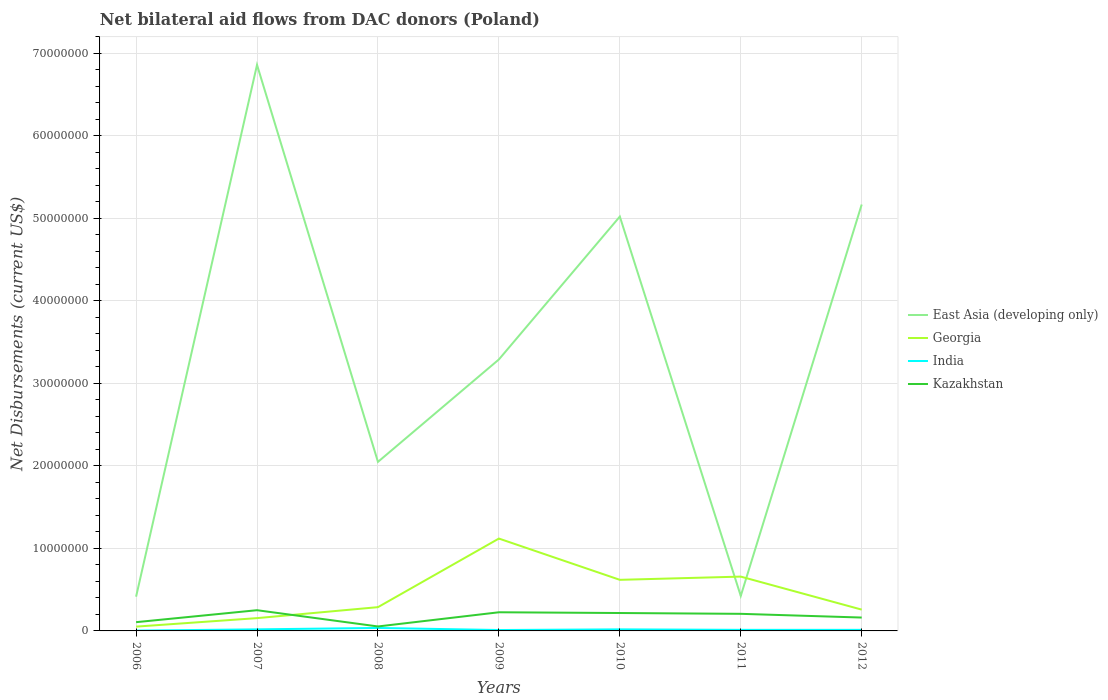How many different coloured lines are there?
Ensure brevity in your answer.  4. Across all years, what is the maximum net bilateral aid flows in East Asia (developing only)?
Ensure brevity in your answer.  4.15e+06. What is the total net bilateral aid flows in Kazakhstan in the graph?
Your answer should be very brief. -1.53e+06. What is the difference between the highest and the second highest net bilateral aid flows in East Asia (developing only)?
Your response must be concise. 6.44e+07. What is the difference between the highest and the lowest net bilateral aid flows in India?
Ensure brevity in your answer.  3. What is the difference between two consecutive major ticks on the Y-axis?
Offer a terse response. 1.00e+07. Are the values on the major ticks of Y-axis written in scientific E-notation?
Provide a short and direct response. No. Does the graph contain any zero values?
Give a very brief answer. No. Where does the legend appear in the graph?
Your answer should be compact. Center right. How many legend labels are there?
Offer a terse response. 4. What is the title of the graph?
Offer a very short reply. Net bilateral aid flows from DAC donors (Poland). Does "Thailand" appear as one of the legend labels in the graph?
Make the answer very short. No. What is the label or title of the X-axis?
Provide a short and direct response. Years. What is the label or title of the Y-axis?
Give a very brief answer. Net Disbursements (current US$). What is the Net Disbursements (current US$) in East Asia (developing only) in 2006?
Ensure brevity in your answer.  4.15e+06. What is the Net Disbursements (current US$) of Georgia in 2006?
Ensure brevity in your answer.  5.20e+05. What is the Net Disbursements (current US$) in India in 2006?
Provide a succinct answer. 4.00e+04. What is the Net Disbursements (current US$) of Kazakhstan in 2006?
Ensure brevity in your answer.  1.06e+06. What is the Net Disbursements (current US$) in East Asia (developing only) in 2007?
Provide a short and direct response. 6.86e+07. What is the Net Disbursements (current US$) of Georgia in 2007?
Offer a very short reply. 1.55e+06. What is the Net Disbursements (current US$) in Kazakhstan in 2007?
Keep it short and to the point. 2.51e+06. What is the Net Disbursements (current US$) in East Asia (developing only) in 2008?
Make the answer very short. 2.05e+07. What is the Net Disbursements (current US$) in Georgia in 2008?
Offer a very short reply. 2.88e+06. What is the Net Disbursements (current US$) of Kazakhstan in 2008?
Your answer should be compact. 5.40e+05. What is the Net Disbursements (current US$) of East Asia (developing only) in 2009?
Ensure brevity in your answer.  3.29e+07. What is the Net Disbursements (current US$) in Georgia in 2009?
Give a very brief answer. 1.12e+07. What is the Net Disbursements (current US$) in India in 2009?
Keep it short and to the point. 1.10e+05. What is the Net Disbursements (current US$) of Kazakhstan in 2009?
Offer a very short reply. 2.26e+06. What is the Net Disbursements (current US$) of East Asia (developing only) in 2010?
Keep it short and to the point. 5.02e+07. What is the Net Disbursements (current US$) in Georgia in 2010?
Your answer should be compact. 6.19e+06. What is the Net Disbursements (current US$) of Kazakhstan in 2010?
Offer a very short reply. 2.17e+06. What is the Net Disbursements (current US$) in East Asia (developing only) in 2011?
Your response must be concise. 4.24e+06. What is the Net Disbursements (current US$) in Georgia in 2011?
Provide a short and direct response. 6.58e+06. What is the Net Disbursements (current US$) of Kazakhstan in 2011?
Your response must be concise. 2.07e+06. What is the Net Disbursements (current US$) of East Asia (developing only) in 2012?
Offer a terse response. 5.17e+07. What is the Net Disbursements (current US$) in Georgia in 2012?
Offer a terse response. 2.58e+06. What is the Net Disbursements (current US$) in India in 2012?
Your answer should be very brief. 1.30e+05. What is the Net Disbursements (current US$) in Kazakhstan in 2012?
Your answer should be very brief. 1.62e+06. Across all years, what is the maximum Net Disbursements (current US$) in East Asia (developing only)?
Make the answer very short. 6.86e+07. Across all years, what is the maximum Net Disbursements (current US$) in Georgia?
Give a very brief answer. 1.12e+07. Across all years, what is the maximum Net Disbursements (current US$) of India?
Offer a very short reply. 3.60e+05. Across all years, what is the maximum Net Disbursements (current US$) in Kazakhstan?
Your answer should be very brief. 2.51e+06. Across all years, what is the minimum Net Disbursements (current US$) in East Asia (developing only)?
Your response must be concise. 4.15e+06. Across all years, what is the minimum Net Disbursements (current US$) of Georgia?
Keep it short and to the point. 5.20e+05. Across all years, what is the minimum Net Disbursements (current US$) of Kazakhstan?
Provide a short and direct response. 5.40e+05. What is the total Net Disbursements (current US$) of East Asia (developing only) in the graph?
Your answer should be compact. 2.32e+08. What is the total Net Disbursements (current US$) in Georgia in the graph?
Offer a terse response. 3.15e+07. What is the total Net Disbursements (current US$) of India in the graph?
Provide a short and direct response. 1.15e+06. What is the total Net Disbursements (current US$) in Kazakhstan in the graph?
Your answer should be compact. 1.22e+07. What is the difference between the Net Disbursements (current US$) in East Asia (developing only) in 2006 and that in 2007?
Offer a very short reply. -6.44e+07. What is the difference between the Net Disbursements (current US$) in Georgia in 2006 and that in 2007?
Keep it short and to the point. -1.03e+06. What is the difference between the Net Disbursements (current US$) in Kazakhstan in 2006 and that in 2007?
Make the answer very short. -1.45e+06. What is the difference between the Net Disbursements (current US$) in East Asia (developing only) in 2006 and that in 2008?
Ensure brevity in your answer.  -1.63e+07. What is the difference between the Net Disbursements (current US$) in Georgia in 2006 and that in 2008?
Your response must be concise. -2.36e+06. What is the difference between the Net Disbursements (current US$) in India in 2006 and that in 2008?
Provide a succinct answer. -3.20e+05. What is the difference between the Net Disbursements (current US$) in Kazakhstan in 2006 and that in 2008?
Make the answer very short. 5.20e+05. What is the difference between the Net Disbursements (current US$) in East Asia (developing only) in 2006 and that in 2009?
Make the answer very short. -2.87e+07. What is the difference between the Net Disbursements (current US$) of Georgia in 2006 and that in 2009?
Keep it short and to the point. -1.07e+07. What is the difference between the Net Disbursements (current US$) in India in 2006 and that in 2009?
Provide a succinct answer. -7.00e+04. What is the difference between the Net Disbursements (current US$) in Kazakhstan in 2006 and that in 2009?
Keep it short and to the point. -1.20e+06. What is the difference between the Net Disbursements (current US$) of East Asia (developing only) in 2006 and that in 2010?
Your answer should be very brief. -4.60e+07. What is the difference between the Net Disbursements (current US$) in Georgia in 2006 and that in 2010?
Your answer should be compact. -5.67e+06. What is the difference between the Net Disbursements (current US$) in India in 2006 and that in 2010?
Provide a succinct answer. -1.50e+05. What is the difference between the Net Disbursements (current US$) of Kazakhstan in 2006 and that in 2010?
Make the answer very short. -1.11e+06. What is the difference between the Net Disbursements (current US$) of Georgia in 2006 and that in 2011?
Provide a short and direct response. -6.06e+06. What is the difference between the Net Disbursements (current US$) in India in 2006 and that in 2011?
Provide a succinct answer. -9.00e+04. What is the difference between the Net Disbursements (current US$) of Kazakhstan in 2006 and that in 2011?
Offer a terse response. -1.01e+06. What is the difference between the Net Disbursements (current US$) of East Asia (developing only) in 2006 and that in 2012?
Keep it short and to the point. -4.75e+07. What is the difference between the Net Disbursements (current US$) of Georgia in 2006 and that in 2012?
Your answer should be very brief. -2.06e+06. What is the difference between the Net Disbursements (current US$) in India in 2006 and that in 2012?
Provide a short and direct response. -9.00e+04. What is the difference between the Net Disbursements (current US$) in Kazakhstan in 2006 and that in 2012?
Your answer should be very brief. -5.60e+05. What is the difference between the Net Disbursements (current US$) of East Asia (developing only) in 2007 and that in 2008?
Your response must be concise. 4.81e+07. What is the difference between the Net Disbursements (current US$) in Georgia in 2007 and that in 2008?
Offer a very short reply. -1.33e+06. What is the difference between the Net Disbursements (current US$) in Kazakhstan in 2007 and that in 2008?
Provide a short and direct response. 1.97e+06. What is the difference between the Net Disbursements (current US$) in East Asia (developing only) in 2007 and that in 2009?
Keep it short and to the point. 3.57e+07. What is the difference between the Net Disbursements (current US$) in Georgia in 2007 and that in 2009?
Keep it short and to the point. -9.64e+06. What is the difference between the Net Disbursements (current US$) of India in 2007 and that in 2009?
Your answer should be very brief. 8.00e+04. What is the difference between the Net Disbursements (current US$) in East Asia (developing only) in 2007 and that in 2010?
Your response must be concise. 1.84e+07. What is the difference between the Net Disbursements (current US$) in Georgia in 2007 and that in 2010?
Provide a succinct answer. -4.64e+06. What is the difference between the Net Disbursements (current US$) of Kazakhstan in 2007 and that in 2010?
Your response must be concise. 3.40e+05. What is the difference between the Net Disbursements (current US$) of East Asia (developing only) in 2007 and that in 2011?
Provide a succinct answer. 6.43e+07. What is the difference between the Net Disbursements (current US$) of Georgia in 2007 and that in 2011?
Ensure brevity in your answer.  -5.03e+06. What is the difference between the Net Disbursements (current US$) of Kazakhstan in 2007 and that in 2011?
Ensure brevity in your answer.  4.40e+05. What is the difference between the Net Disbursements (current US$) of East Asia (developing only) in 2007 and that in 2012?
Offer a terse response. 1.69e+07. What is the difference between the Net Disbursements (current US$) in Georgia in 2007 and that in 2012?
Offer a terse response. -1.03e+06. What is the difference between the Net Disbursements (current US$) of Kazakhstan in 2007 and that in 2012?
Keep it short and to the point. 8.90e+05. What is the difference between the Net Disbursements (current US$) of East Asia (developing only) in 2008 and that in 2009?
Offer a terse response. -1.24e+07. What is the difference between the Net Disbursements (current US$) in Georgia in 2008 and that in 2009?
Ensure brevity in your answer.  -8.31e+06. What is the difference between the Net Disbursements (current US$) of India in 2008 and that in 2009?
Offer a terse response. 2.50e+05. What is the difference between the Net Disbursements (current US$) of Kazakhstan in 2008 and that in 2009?
Give a very brief answer. -1.72e+06. What is the difference between the Net Disbursements (current US$) in East Asia (developing only) in 2008 and that in 2010?
Offer a terse response. -2.97e+07. What is the difference between the Net Disbursements (current US$) in Georgia in 2008 and that in 2010?
Make the answer very short. -3.31e+06. What is the difference between the Net Disbursements (current US$) of Kazakhstan in 2008 and that in 2010?
Your answer should be very brief. -1.63e+06. What is the difference between the Net Disbursements (current US$) in East Asia (developing only) in 2008 and that in 2011?
Provide a succinct answer. 1.62e+07. What is the difference between the Net Disbursements (current US$) of Georgia in 2008 and that in 2011?
Give a very brief answer. -3.70e+06. What is the difference between the Net Disbursements (current US$) of Kazakhstan in 2008 and that in 2011?
Your answer should be very brief. -1.53e+06. What is the difference between the Net Disbursements (current US$) in East Asia (developing only) in 2008 and that in 2012?
Ensure brevity in your answer.  -3.12e+07. What is the difference between the Net Disbursements (current US$) in Georgia in 2008 and that in 2012?
Ensure brevity in your answer.  3.00e+05. What is the difference between the Net Disbursements (current US$) of Kazakhstan in 2008 and that in 2012?
Provide a short and direct response. -1.08e+06. What is the difference between the Net Disbursements (current US$) in East Asia (developing only) in 2009 and that in 2010?
Your answer should be compact. -1.73e+07. What is the difference between the Net Disbursements (current US$) of Kazakhstan in 2009 and that in 2010?
Provide a short and direct response. 9.00e+04. What is the difference between the Net Disbursements (current US$) of East Asia (developing only) in 2009 and that in 2011?
Make the answer very short. 2.86e+07. What is the difference between the Net Disbursements (current US$) in Georgia in 2009 and that in 2011?
Offer a terse response. 4.61e+06. What is the difference between the Net Disbursements (current US$) in India in 2009 and that in 2011?
Provide a succinct answer. -2.00e+04. What is the difference between the Net Disbursements (current US$) of East Asia (developing only) in 2009 and that in 2012?
Provide a short and direct response. -1.88e+07. What is the difference between the Net Disbursements (current US$) of Georgia in 2009 and that in 2012?
Provide a short and direct response. 8.61e+06. What is the difference between the Net Disbursements (current US$) in India in 2009 and that in 2012?
Your answer should be compact. -2.00e+04. What is the difference between the Net Disbursements (current US$) of Kazakhstan in 2009 and that in 2012?
Make the answer very short. 6.40e+05. What is the difference between the Net Disbursements (current US$) in East Asia (developing only) in 2010 and that in 2011?
Keep it short and to the point. 4.60e+07. What is the difference between the Net Disbursements (current US$) of Georgia in 2010 and that in 2011?
Your answer should be very brief. -3.90e+05. What is the difference between the Net Disbursements (current US$) of Kazakhstan in 2010 and that in 2011?
Your answer should be very brief. 1.00e+05. What is the difference between the Net Disbursements (current US$) of East Asia (developing only) in 2010 and that in 2012?
Offer a very short reply. -1.46e+06. What is the difference between the Net Disbursements (current US$) of Georgia in 2010 and that in 2012?
Keep it short and to the point. 3.61e+06. What is the difference between the Net Disbursements (current US$) of India in 2010 and that in 2012?
Your answer should be very brief. 6.00e+04. What is the difference between the Net Disbursements (current US$) of East Asia (developing only) in 2011 and that in 2012?
Make the answer very short. -4.74e+07. What is the difference between the Net Disbursements (current US$) of Kazakhstan in 2011 and that in 2012?
Give a very brief answer. 4.50e+05. What is the difference between the Net Disbursements (current US$) of East Asia (developing only) in 2006 and the Net Disbursements (current US$) of Georgia in 2007?
Your answer should be very brief. 2.60e+06. What is the difference between the Net Disbursements (current US$) in East Asia (developing only) in 2006 and the Net Disbursements (current US$) in India in 2007?
Provide a short and direct response. 3.96e+06. What is the difference between the Net Disbursements (current US$) in East Asia (developing only) in 2006 and the Net Disbursements (current US$) in Kazakhstan in 2007?
Give a very brief answer. 1.64e+06. What is the difference between the Net Disbursements (current US$) in Georgia in 2006 and the Net Disbursements (current US$) in India in 2007?
Offer a terse response. 3.30e+05. What is the difference between the Net Disbursements (current US$) of Georgia in 2006 and the Net Disbursements (current US$) of Kazakhstan in 2007?
Offer a terse response. -1.99e+06. What is the difference between the Net Disbursements (current US$) of India in 2006 and the Net Disbursements (current US$) of Kazakhstan in 2007?
Keep it short and to the point. -2.47e+06. What is the difference between the Net Disbursements (current US$) of East Asia (developing only) in 2006 and the Net Disbursements (current US$) of Georgia in 2008?
Give a very brief answer. 1.27e+06. What is the difference between the Net Disbursements (current US$) in East Asia (developing only) in 2006 and the Net Disbursements (current US$) in India in 2008?
Offer a very short reply. 3.79e+06. What is the difference between the Net Disbursements (current US$) of East Asia (developing only) in 2006 and the Net Disbursements (current US$) of Kazakhstan in 2008?
Offer a terse response. 3.61e+06. What is the difference between the Net Disbursements (current US$) of Georgia in 2006 and the Net Disbursements (current US$) of Kazakhstan in 2008?
Offer a very short reply. -2.00e+04. What is the difference between the Net Disbursements (current US$) in India in 2006 and the Net Disbursements (current US$) in Kazakhstan in 2008?
Your answer should be very brief. -5.00e+05. What is the difference between the Net Disbursements (current US$) in East Asia (developing only) in 2006 and the Net Disbursements (current US$) in Georgia in 2009?
Your answer should be very brief. -7.04e+06. What is the difference between the Net Disbursements (current US$) in East Asia (developing only) in 2006 and the Net Disbursements (current US$) in India in 2009?
Make the answer very short. 4.04e+06. What is the difference between the Net Disbursements (current US$) of East Asia (developing only) in 2006 and the Net Disbursements (current US$) of Kazakhstan in 2009?
Provide a short and direct response. 1.89e+06. What is the difference between the Net Disbursements (current US$) of Georgia in 2006 and the Net Disbursements (current US$) of Kazakhstan in 2009?
Offer a very short reply. -1.74e+06. What is the difference between the Net Disbursements (current US$) in India in 2006 and the Net Disbursements (current US$) in Kazakhstan in 2009?
Offer a terse response. -2.22e+06. What is the difference between the Net Disbursements (current US$) in East Asia (developing only) in 2006 and the Net Disbursements (current US$) in Georgia in 2010?
Provide a short and direct response. -2.04e+06. What is the difference between the Net Disbursements (current US$) in East Asia (developing only) in 2006 and the Net Disbursements (current US$) in India in 2010?
Make the answer very short. 3.96e+06. What is the difference between the Net Disbursements (current US$) of East Asia (developing only) in 2006 and the Net Disbursements (current US$) of Kazakhstan in 2010?
Keep it short and to the point. 1.98e+06. What is the difference between the Net Disbursements (current US$) in Georgia in 2006 and the Net Disbursements (current US$) in India in 2010?
Give a very brief answer. 3.30e+05. What is the difference between the Net Disbursements (current US$) in Georgia in 2006 and the Net Disbursements (current US$) in Kazakhstan in 2010?
Provide a short and direct response. -1.65e+06. What is the difference between the Net Disbursements (current US$) of India in 2006 and the Net Disbursements (current US$) of Kazakhstan in 2010?
Your answer should be compact. -2.13e+06. What is the difference between the Net Disbursements (current US$) in East Asia (developing only) in 2006 and the Net Disbursements (current US$) in Georgia in 2011?
Offer a terse response. -2.43e+06. What is the difference between the Net Disbursements (current US$) of East Asia (developing only) in 2006 and the Net Disbursements (current US$) of India in 2011?
Your answer should be compact. 4.02e+06. What is the difference between the Net Disbursements (current US$) in East Asia (developing only) in 2006 and the Net Disbursements (current US$) in Kazakhstan in 2011?
Provide a succinct answer. 2.08e+06. What is the difference between the Net Disbursements (current US$) in Georgia in 2006 and the Net Disbursements (current US$) in Kazakhstan in 2011?
Offer a terse response. -1.55e+06. What is the difference between the Net Disbursements (current US$) in India in 2006 and the Net Disbursements (current US$) in Kazakhstan in 2011?
Give a very brief answer. -2.03e+06. What is the difference between the Net Disbursements (current US$) of East Asia (developing only) in 2006 and the Net Disbursements (current US$) of Georgia in 2012?
Make the answer very short. 1.57e+06. What is the difference between the Net Disbursements (current US$) in East Asia (developing only) in 2006 and the Net Disbursements (current US$) in India in 2012?
Your response must be concise. 4.02e+06. What is the difference between the Net Disbursements (current US$) of East Asia (developing only) in 2006 and the Net Disbursements (current US$) of Kazakhstan in 2012?
Your answer should be very brief. 2.53e+06. What is the difference between the Net Disbursements (current US$) in Georgia in 2006 and the Net Disbursements (current US$) in India in 2012?
Provide a short and direct response. 3.90e+05. What is the difference between the Net Disbursements (current US$) in Georgia in 2006 and the Net Disbursements (current US$) in Kazakhstan in 2012?
Offer a very short reply. -1.10e+06. What is the difference between the Net Disbursements (current US$) in India in 2006 and the Net Disbursements (current US$) in Kazakhstan in 2012?
Keep it short and to the point. -1.58e+06. What is the difference between the Net Disbursements (current US$) of East Asia (developing only) in 2007 and the Net Disbursements (current US$) of Georgia in 2008?
Your answer should be compact. 6.57e+07. What is the difference between the Net Disbursements (current US$) of East Asia (developing only) in 2007 and the Net Disbursements (current US$) of India in 2008?
Provide a succinct answer. 6.82e+07. What is the difference between the Net Disbursements (current US$) of East Asia (developing only) in 2007 and the Net Disbursements (current US$) of Kazakhstan in 2008?
Ensure brevity in your answer.  6.80e+07. What is the difference between the Net Disbursements (current US$) in Georgia in 2007 and the Net Disbursements (current US$) in India in 2008?
Give a very brief answer. 1.19e+06. What is the difference between the Net Disbursements (current US$) in Georgia in 2007 and the Net Disbursements (current US$) in Kazakhstan in 2008?
Provide a succinct answer. 1.01e+06. What is the difference between the Net Disbursements (current US$) of India in 2007 and the Net Disbursements (current US$) of Kazakhstan in 2008?
Make the answer very short. -3.50e+05. What is the difference between the Net Disbursements (current US$) in East Asia (developing only) in 2007 and the Net Disbursements (current US$) in Georgia in 2009?
Your response must be concise. 5.74e+07. What is the difference between the Net Disbursements (current US$) of East Asia (developing only) in 2007 and the Net Disbursements (current US$) of India in 2009?
Your answer should be compact. 6.85e+07. What is the difference between the Net Disbursements (current US$) of East Asia (developing only) in 2007 and the Net Disbursements (current US$) of Kazakhstan in 2009?
Provide a succinct answer. 6.63e+07. What is the difference between the Net Disbursements (current US$) of Georgia in 2007 and the Net Disbursements (current US$) of India in 2009?
Your answer should be compact. 1.44e+06. What is the difference between the Net Disbursements (current US$) in Georgia in 2007 and the Net Disbursements (current US$) in Kazakhstan in 2009?
Provide a short and direct response. -7.10e+05. What is the difference between the Net Disbursements (current US$) of India in 2007 and the Net Disbursements (current US$) of Kazakhstan in 2009?
Your answer should be compact. -2.07e+06. What is the difference between the Net Disbursements (current US$) of East Asia (developing only) in 2007 and the Net Disbursements (current US$) of Georgia in 2010?
Offer a very short reply. 6.24e+07. What is the difference between the Net Disbursements (current US$) in East Asia (developing only) in 2007 and the Net Disbursements (current US$) in India in 2010?
Provide a short and direct response. 6.84e+07. What is the difference between the Net Disbursements (current US$) of East Asia (developing only) in 2007 and the Net Disbursements (current US$) of Kazakhstan in 2010?
Keep it short and to the point. 6.64e+07. What is the difference between the Net Disbursements (current US$) of Georgia in 2007 and the Net Disbursements (current US$) of India in 2010?
Your answer should be compact. 1.36e+06. What is the difference between the Net Disbursements (current US$) of Georgia in 2007 and the Net Disbursements (current US$) of Kazakhstan in 2010?
Your answer should be compact. -6.20e+05. What is the difference between the Net Disbursements (current US$) of India in 2007 and the Net Disbursements (current US$) of Kazakhstan in 2010?
Offer a very short reply. -1.98e+06. What is the difference between the Net Disbursements (current US$) of East Asia (developing only) in 2007 and the Net Disbursements (current US$) of Georgia in 2011?
Your response must be concise. 6.20e+07. What is the difference between the Net Disbursements (current US$) in East Asia (developing only) in 2007 and the Net Disbursements (current US$) in India in 2011?
Your response must be concise. 6.84e+07. What is the difference between the Net Disbursements (current US$) of East Asia (developing only) in 2007 and the Net Disbursements (current US$) of Kazakhstan in 2011?
Provide a succinct answer. 6.65e+07. What is the difference between the Net Disbursements (current US$) in Georgia in 2007 and the Net Disbursements (current US$) in India in 2011?
Offer a terse response. 1.42e+06. What is the difference between the Net Disbursements (current US$) of Georgia in 2007 and the Net Disbursements (current US$) of Kazakhstan in 2011?
Your response must be concise. -5.20e+05. What is the difference between the Net Disbursements (current US$) in India in 2007 and the Net Disbursements (current US$) in Kazakhstan in 2011?
Give a very brief answer. -1.88e+06. What is the difference between the Net Disbursements (current US$) of East Asia (developing only) in 2007 and the Net Disbursements (current US$) of Georgia in 2012?
Offer a very short reply. 6.60e+07. What is the difference between the Net Disbursements (current US$) of East Asia (developing only) in 2007 and the Net Disbursements (current US$) of India in 2012?
Make the answer very short. 6.84e+07. What is the difference between the Net Disbursements (current US$) in East Asia (developing only) in 2007 and the Net Disbursements (current US$) in Kazakhstan in 2012?
Provide a short and direct response. 6.70e+07. What is the difference between the Net Disbursements (current US$) in Georgia in 2007 and the Net Disbursements (current US$) in India in 2012?
Keep it short and to the point. 1.42e+06. What is the difference between the Net Disbursements (current US$) of Georgia in 2007 and the Net Disbursements (current US$) of Kazakhstan in 2012?
Make the answer very short. -7.00e+04. What is the difference between the Net Disbursements (current US$) of India in 2007 and the Net Disbursements (current US$) of Kazakhstan in 2012?
Provide a succinct answer. -1.43e+06. What is the difference between the Net Disbursements (current US$) of East Asia (developing only) in 2008 and the Net Disbursements (current US$) of Georgia in 2009?
Make the answer very short. 9.29e+06. What is the difference between the Net Disbursements (current US$) in East Asia (developing only) in 2008 and the Net Disbursements (current US$) in India in 2009?
Keep it short and to the point. 2.04e+07. What is the difference between the Net Disbursements (current US$) in East Asia (developing only) in 2008 and the Net Disbursements (current US$) in Kazakhstan in 2009?
Make the answer very short. 1.82e+07. What is the difference between the Net Disbursements (current US$) of Georgia in 2008 and the Net Disbursements (current US$) of India in 2009?
Ensure brevity in your answer.  2.77e+06. What is the difference between the Net Disbursements (current US$) in Georgia in 2008 and the Net Disbursements (current US$) in Kazakhstan in 2009?
Offer a terse response. 6.20e+05. What is the difference between the Net Disbursements (current US$) in India in 2008 and the Net Disbursements (current US$) in Kazakhstan in 2009?
Your answer should be compact. -1.90e+06. What is the difference between the Net Disbursements (current US$) of East Asia (developing only) in 2008 and the Net Disbursements (current US$) of Georgia in 2010?
Your response must be concise. 1.43e+07. What is the difference between the Net Disbursements (current US$) of East Asia (developing only) in 2008 and the Net Disbursements (current US$) of India in 2010?
Provide a short and direct response. 2.03e+07. What is the difference between the Net Disbursements (current US$) of East Asia (developing only) in 2008 and the Net Disbursements (current US$) of Kazakhstan in 2010?
Your answer should be very brief. 1.83e+07. What is the difference between the Net Disbursements (current US$) in Georgia in 2008 and the Net Disbursements (current US$) in India in 2010?
Your answer should be very brief. 2.69e+06. What is the difference between the Net Disbursements (current US$) in Georgia in 2008 and the Net Disbursements (current US$) in Kazakhstan in 2010?
Your answer should be compact. 7.10e+05. What is the difference between the Net Disbursements (current US$) of India in 2008 and the Net Disbursements (current US$) of Kazakhstan in 2010?
Provide a succinct answer. -1.81e+06. What is the difference between the Net Disbursements (current US$) in East Asia (developing only) in 2008 and the Net Disbursements (current US$) in Georgia in 2011?
Offer a terse response. 1.39e+07. What is the difference between the Net Disbursements (current US$) of East Asia (developing only) in 2008 and the Net Disbursements (current US$) of India in 2011?
Give a very brief answer. 2.04e+07. What is the difference between the Net Disbursements (current US$) of East Asia (developing only) in 2008 and the Net Disbursements (current US$) of Kazakhstan in 2011?
Offer a terse response. 1.84e+07. What is the difference between the Net Disbursements (current US$) in Georgia in 2008 and the Net Disbursements (current US$) in India in 2011?
Offer a very short reply. 2.75e+06. What is the difference between the Net Disbursements (current US$) of Georgia in 2008 and the Net Disbursements (current US$) of Kazakhstan in 2011?
Provide a short and direct response. 8.10e+05. What is the difference between the Net Disbursements (current US$) of India in 2008 and the Net Disbursements (current US$) of Kazakhstan in 2011?
Your answer should be compact. -1.71e+06. What is the difference between the Net Disbursements (current US$) in East Asia (developing only) in 2008 and the Net Disbursements (current US$) in Georgia in 2012?
Keep it short and to the point. 1.79e+07. What is the difference between the Net Disbursements (current US$) in East Asia (developing only) in 2008 and the Net Disbursements (current US$) in India in 2012?
Offer a very short reply. 2.04e+07. What is the difference between the Net Disbursements (current US$) of East Asia (developing only) in 2008 and the Net Disbursements (current US$) of Kazakhstan in 2012?
Offer a very short reply. 1.89e+07. What is the difference between the Net Disbursements (current US$) of Georgia in 2008 and the Net Disbursements (current US$) of India in 2012?
Provide a succinct answer. 2.75e+06. What is the difference between the Net Disbursements (current US$) in Georgia in 2008 and the Net Disbursements (current US$) in Kazakhstan in 2012?
Offer a very short reply. 1.26e+06. What is the difference between the Net Disbursements (current US$) of India in 2008 and the Net Disbursements (current US$) of Kazakhstan in 2012?
Provide a short and direct response. -1.26e+06. What is the difference between the Net Disbursements (current US$) of East Asia (developing only) in 2009 and the Net Disbursements (current US$) of Georgia in 2010?
Give a very brief answer. 2.67e+07. What is the difference between the Net Disbursements (current US$) in East Asia (developing only) in 2009 and the Net Disbursements (current US$) in India in 2010?
Your answer should be very brief. 3.27e+07. What is the difference between the Net Disbursements (current US$) of East Asia (developing only) in 2009 and the Net Disbursements (current US$) of Kazakhstan in 2010?
Provide a succinct answer. 3.07e+07. What is the difference between the Net Disbursements (current US$) of Georgia in 2009 and the Net Disbursements (current US$) of India in 2010?
Give a very brief answer. 1.10e+07. What is the difference between the Net Disbursements (current US$) in Georgia in 2009 and the Net Disbursements (current US$) in Kazakhstan in 2010?
Provide a short and direct response. 9.02e+06. What is the difference between the Net Disbursements (current US$) in India in 2009 and the Net Disbursements (current US$) in Kazakhstan in 2010?
Offer a very short reply. -2.06e+06. What is the difference between the Net Disbursements (current US$) of East Asia (developing only) in 2009 and the Net Disbursements (current US$) of Georgia in 2011?
Offer a terse response. 2.63e+07. What is the difference between the Net Disbursements (current US$) in East Asia (developing only) in 2009 and the Net Disbursements (current US$) in India in 2011?
Offer a terse response. 3.28e+07. What is the difference between the Net Disbursements (current US$) of East Asia (developing only) in 2009 and the Net Disbursements (current US$) of Kazakhstan in 2011?
Give a very brief answer. 3.08e+07. What is the difference between the Net Disbursements (current US$) of Georgia in 2009 and the Net Disbursements (current US$) of India in 2011?
Your answer should be very brief. 1.11e+07. What is the difference between the Net Disbursements (current US$) of Georgia in 2009 and the Net Disbursements (current US$) of Kazakhstan in 2011?
Your answer should be very brief. 9.12e+06. What is the difference between the Net Disbursements (current US$) of India in 2009 and the Net Disbursements (current US$) of Kazakhstan in 2011?
Offer a terse response. -1.96e+06. What is the difference between the Net Disbursements (current US$) in East Asia (developing only) in 2009 and the Net Disbursements (current US$) in Georgia in 2012?
Give a very brief answer. 3.03e+07. What is the difference between the Net Disbursements (current US$) in East Asia (developing only) in 2009 and the Net Disbursements (current US$) in India in 2012?
Provide a succinct answer. 3.28e+07. What is the difference between the Net Disbursements (current US$) of East Asia (developing only) in 2009 and the Net Disbursements (current US$) of Kazakhstan in 2012?
Provide a short and direct response. 3.13e+07. What is the difference between the Net Disbursements (current US$) of Georgia in 2009 and the Net Disbursements (current US$) of India in 2012?
Keep it short and to the point. 1.11e+07. What is the difference between the Net Disbursements (current US$) of Georgia in 2009 and the Net Disbursements (current US$) of Kazakhstan in 2012?
Your answer should be compact. 9.57e+06. What is the difference between the Net Disbursements (current US$) in India in 2009 and the Net Disbursements (current US$) in Kazakhstan in 2012?
Make the answer very short. -1.51e+06. What is the difference between the Net Disbursements (current US$) of East Asia (developing only) in 2010 and the Net Disbursements (current US$) of Georgia in 2011?
Offer a terse response. 4.36e+07. What is the difference between the Net Disbursements (current US$) in East Asia (developing only) in 2010 and the Net Disbursements (current US$) in India in 2011?
Your answer should be very brief. 5.01e+07. What is the difference between the Net Disbursements (current US$) of East Asia (developing only) in 2010 and the Net Disbursements (current US$) of Kazakhstan in 2011?
Make the answer very short. 4.81e+07. What is the difference between the Net Disbursements (current US$) of Georgia in 2010 and the Net Disbursements (current US$) of India in 2011?
Offer a very short reply. 6.06e+06. What is the difference between the Net Disbursements (current US$) of Georgia in 2010 and the Net Disbursements (current US$) of Kazakhstan in 2011?
Offer a very short reply. 4.12e+06. What is the difference between the Net Disbursements (current US$) of India in 2010 and the Net Disbursements (current US$) of Kazakhstan in 2011?
Your answer should be very brief. -1.88e+06. What is the difference between the Net Disbursements (current US$) of East Asia (developing only) in 2010 and the Net Disbursements (current US$) of Georgia in 2012?
Provide a short and direct response. 4.76e+07. What is the difference between the Net Disbursements (current US$) of East Asia (developing only) in 2010 and the Net Disbursements (current US$) of India in 2012?
Ensure brevity in your answer.  5.01e+07. What is the difference between the Net Disbursements (current US$) of East Asia (developing only) in 2010 and the Net Disbursements (current US$) of Kazakhstan in 2012?
Your response must be concise. 4.86e+07. What is the difference between the Net Disbursements (current US$) in Georgia in 2010 and the Net Disbursements (current US$) in India in 2012?
Provide a succinct answer. 6.06e+06. What is the difference between the Net Disbursements (current US$) in Georgia in 2010 and the Net Disbursements (current US$) in Kazakhstan in 2012?
Offer a terse response. 4.57e+06. What is the difference between the Net Disbursements (current US$) of India in 2010 and the Net Disbursements (current US$) of Kazakhstan in 2012?
Your answer should be very brief. -1.43e+06. What is the difference between the Net Disbursements (current US$) of East Asia (developing only) in 2011 and the Net Disbursements (current US$) of Georgia in 2012?
Your answer should be compact. 1.66e+06. What is the difference between the Net Disbursements (current US$) of East Asia (developing only) in 2011 and the Net Disbursements (current US$) of India in 2012?
Offer a very short reply. 4.11e+06. What is the difference between the Net Disbursements (current US$) in East Asia (developing only) in 2011 and the Net Disbursements (current US$) in Kazakhstan in 2012?
Give a very brief answer. 2.62e+06. What is the difference between the Net Disbursements (current US$) in Georgia in 2011 and the Net Disbursements (current US$) in India in 2012?
Provide a succinct answer. 6.45e+06. What is the difference between the Net Disbursements (current US$) of Georgia in 2011 and the Net Disbursements (current US$) of Kazakhstan in 2012?
Offer a terse response. 4.96e+06. What is the difference between the Net Disbursements (current US$) in India in 2011 and the Net Disbursements (current US$) in Kazakhstan in 2012?
Give a very brief answer. -1.49e+06. What is the average Net Disbursements (current US$) of East Asia (developing only) per year?
Offer a terse response. 3.32e+07. What is the average Net Disbursements (current US$) in Georgia per year?
Provide a succinct answer. 4.50e+06. What is the average Net Disbursements (current US$) in India per year?
Provide a succinct answer. 1.64e+05. What is the average Net Disbursements (current US$) of Kazakhstan per year?
Offer a very short reply. 1.75e+06. In the year 2006, what is the difference between the Net Disbursements (current US$) in East Asia (developing only) and Net Disbursements (current US$) in Georgia?
Your answer should be compact. 3.63e+06. In the year 2006, what is the difference between the Net Disbursements (current US$) in East Asia (developing only) and Net Disbursements (current US$) in India?
Give a very brief answer. 4.11e+06. In the year 2006, what is the difference between the Net Disbursements (current US$) of East Asia (developing only) and Net Disbursements (current US$) of Kazakhstan?
Offer a very short reply. 3.09e+06. In the year 2006, what is the difference between the Net Disbursements (current US$) in Georgia and Net Disbursements (current US$) in India?
Your response must be concise. 4.80e+05. In the year 2006, what is the difference between the Net Disbursements (current US$) of Georgia and Net Disbursements (current US$) of Kazakhstan?
Make the answer very short. -5.40e+05. In the year 2006, what is the difference between the Net Disbursements (current US$) in India and Net Disbursements (current US$) in Kazakhstan?
Provide a short and direct response. -1.02e+06. In the year 2007, what is the difference between the Net Disbursements (current US$) of East Asia (developing only) and Net Disbursements (current US$) of Georgia?
Keep it short and to the point. 6.70e+07. In the year 2007, what is the difference between the Net Disbursements (current US$) in East Asia (developing only) and Net Disbursements (current US$) in India?
Make the answer very short. 6.84e+07. In the year 2007, what is the difference between the Net Disbursements (current US$) of East Asia (developing only) and Net Disbursements (current US$) of Kazakhstan?
Your response must be concise. 6.61e+07. In the year 2007, what is the difference between the Net Disbursements (current US$) in Georgia and Net Disbursements (current US$) in India?
Ensure brevity in your answer.  1.36e+06. In the year 2007, what is the difference between the Net Disbursements (current US$) of Georgia and Net Disbursements (current US$) of Kazakhstan?
Ensure brevity in your answer.  -9.60e+05. In the year 2007, what is the difference between the Net Disbursements (current US$) of India and Net Disbursements (current US$) of Kazakhstan?
Ensure brevity in your answer.  -2.32e+06. In the year 2008, what is the difference between the Net Disbursements (current US$) of East Asia (developing only) and Net Disbursements (current US$) of Georgia?
Provide a succinct answer. 1.76e+07. In the year 2008, what is the difference between the Net Disbursements (current US$) of East Asia (developing only) and Net Disbursements (current US$) of India?
Provide a succinct answer. 2.01e+07. In the year 2008, what is the difference between the Net Disbursements (current US$) of East Asia (developing only) and Net Disbursements (current US$) of Kazakhstan?
Provide a short and direct response. 1.99e+07. In the year 2008, what is the difference between the Net Disbursements (current US$) in Georgia and Net Disbursements (current US$) in India?
Ensure brevity in your answer.  2.52e+06. In the year 2008, what is the difference between the Net Disbursements (current US$) in Georgia and Net Disbursements (current US$) in Kazakhstan?
Provide a short and direct response. 2.34e+06. In the year 2009, what is the difference between the Net Disbursements (current US$) of East Asia (developing only) and Net Disbursements (current US$) of Georgia?
Give a very brief answer. 2.17e+07. In the year 2009, what is the difference between the Net Disbursements (current US$) in East Asia (developing only) and Net Disbursements (current US$) in India?
Offer a very short reply. 3.28e+07. In the year 2009, what is the difference between the Net Disbursements (current US$) in East Asia (developing only) and Net Disbursements (current US$) in Kazakhstan?
Offer a terse response. 3.06e+07. In the year 2009, what is the difference between the Net Disbursements (current US$) in Georgia and Net Disbursements (current US$) in India?
Ensure brevity in your answer.  1.11e+07. In the year 2009, what is the difference between the Net Disbursements (current US$) in Georgia and Net Disbursements (current US$) in Kazakhstan?
Give a very brief answer. 8.93e+06. In the year 2009, what is the difference between the Net Disbursements (current US$) of India and Net Disbursements (current US$) of Kazakhstan?
Give a very brief answer. -2.15e+06. In the year 2010, what is the difference between the Net Disbursements (current US$) in East Asia (developing only) and Net Disbursements (current US$) in Georgia?
Offer a terse response. 4.40e+07. In the year 2010, what is the difference between the Net Disbursements (current US$) in East Asia (developing only) and Net Disbursements (current US$) in India?
Offer a very short reply. 5.00e+07. In the year 2010, what is the difference between the Net Disbursements (current US$) in East Asia (developing only) and Net Disbursements (current US$) in Kazakhstan?
Give a very brief answer. 4.80e+07. In the year 2010, what is the difference between the Net Disbursements (current US$) of Georgia and Net Disbursements (current US$) of India?
Provide a short and direct response. 6.00e+06. In the year 2010, what is the difference between the Net Disbursements (current US$) of Georgia and Net Disbursements (current US$) of Kazakhstan?
Provide a succinct answer. 4.02e+06. In the year 2010, what is the difference between the Net Disbursements (current US$) of India and Net Disbursements (current US$) of Kazakhstan?
Your response must be concise. -1.98e+06. In the year 2011, what is the difference between the Net Disbursements (current US$) of East Asia (developing only) and Net Disbursements (current US$) of Georgia?
Offer a very short reply. -2.34e+06. In the year 2011, what is the difference between the Net Disbursements (current US$) in East Asia (developing only) and Net Disbursements (current US$) in India?
Offer a very short reply. 4.11e+06. In the year 2011, what is the difference between the Net Disbursements (current US$) in East Asia (developing only) and Net Disbursements (current US$) in Kazakhstan?
Keep it short and to the point. 2.17e+06. In the year 2011, what is the difference between the Net Disbursements (current US$) in Georgia and Net Disbursements (current US$) in India?
Give a very brief answer. 6.45e+06. In the year 2011, what is the difference between the Net Disbursements (current US$) of Georgia and Net Disbursements (current US$) of Kazakhstan?
Your answer should be compact. 4.51e+06. In the year 2011, what is the difference between the Net Disbursements (current US$) in India and Net Disbursements (current US$) in Kazakhstan?
Your answer should be very brief. -1.94e+06. In the year 2012, what is the difference between the Net Disbursements (current US$) of East Asia (developing only) and Net Disbursements (current US$) of Georgia?
Give a very brief answer. 4.91e+07. In the year 2012, what is the difference between the Net Disbursements (current US$) of East Asia (developing only) and Net Disbursements (current US$) of India?
Offer a terse response. 5.15e+07. In the year 2012, what is the difference between the Net Disbursements (current US$) of East Asia (developing only) and Net Disbursements (current US$) of Kazakhstan?
Provide a short and direct response. 5.00e+07. In the year 2012, what is the difference between the Net Disbursements (current US$) in Georgia and Net Disbursements (current US$) in India?
Make the answer very short. 2.45e+06. In the year 2012, what is the difference between the Net Disbursements (current US$) in Georgia and Net Disbursements (current US$) in Kazakhstan?
Your answer should be compact. 9.60e+05. In the year 2012, what is the difference between the Net Disbursements (current US$) in India and Net Disbursements (current US$) in Kazakhstan?
Make the answer very short. -1.49e+06. What is the ratio of the Net Disbursements (current US$) of East Asia (developing only) in 2006 to that in 2007?
Provide a short and direct response. 0.06. What is the ratio of the Net Disbursements (current US$) in Georgia in 2006 to that in 2007?
Ensure brevity in your answer.  0.34. What is the ratio of the Net Disbursements (current US$) of India in 2006 to that in 2007?
Keep it short and to the point. 0.21. What is the ratio of the Net Disbursements (current US$) of Kazakhstan in 2006 to that in 2007?
Your answer should be compact. 0.42. What is the ratio of the Net Disbursements (current US$) of East Asia (developing only) in 2006 to that in 2008?
Keep it short and to the point. 0.2. What is the ratio of the Net Disbursements (current US$) of Georgia in 2006 to that in 2008?
Your answer should be compact. 0.18. What is the ratio of the Net Disbursements (current US$) in India in 2006 to that in 2008?
Offer a very short reply. 0.11. What is the ratio of the Net Disbursements (current US$) in Kazakhstan in 2006 to that in 2008?
Your answer should be compact. 1.96. What is the ratio of the Net Disbursements (current US$) in East Asia (developing only) in 2006 to that in 2009?
Your answer should be very brief. 0.13. What is the ratio of the Net Disbursements (current US$) of Georgia in 2006 to that in 2009?
Your answer should be very brief. 0.05. What is the ratio of the Net Disbursements (current US$) in India in 2006 to that in 2009?
Make the answer very short. 0.36. What is the ratio of the Net Disbursements (current US$) of Kazakhstan in 2006 to that in 2009?
Offer a terse response. 0.47. What is the ratio of the Net Disbursements (current US$) in East Asia (developing only) in 2006 to that in 2010?
Offer a very short reply. 0.08. What is the ratio of the Net Disbursements (current US$) of Georgia in 2006 to that in 2010?
Your answer should be compact. 0.08. What is the ratio of the Net Disbursements (current US$) of India in 2006 to that in 2010?
Offer a terse response. 0.21. What is the ratio of the Net Disbursements (current US$) of Kazakhstan in 2006 to that in 2010?
Your response must be concise. 0.49. What is the ratio of the Net Disbursements (current US$) in East Asia (developing only) in 2006 to that in 2011?
Your answer should be compact. 0.98. What is the ratio of the Net Disbursements (current US$) in Georgia in 2006 to that in 2011?
Provide a short and direct response. 0.08. What is the ratio of the Net Disbursements (current US$) of India in 2006 to that in 2011?
Your answer should be compact. 0.31. What is the ratio of the Net Disbursements (current US$) of Kazakhstan in 2006 to that in 2011?
Provide a short and direct response. 0.51. What is the ratio of the Net Disbursements (current US$) in East Asia (developing only) in 2006 to that in 2012?
Offer a very short reply. 0.08. What is the ratio of the Net Disbursements (current US$) in Georgia in 2006 to that in 2012?
Offer a terse response. 0.2. What is the ratio of the Net Disbursements (current US$) of India in 2006 to that in 2012?
Make the answer very short. 0.31. What is the ratio of the Net Disbursements (current US$) of Kazakhstan in 2006 to that in 2012?
Keep it short and to the point. 0.65. What is the ratio of the Net Disbursements (current US$) of East Asia (developing only) in 2007 to that in 2008?
Ensure brevity in your answer.  3.35. What is the ratio of the Net Disbursements (current US$) in Georgia in 2007 to that in 2008?
Make the answer very short. 0.54. What is the ratio of the Net Disbursements (current US$) in India in 2007 to that in 2008?
Give a very brief answer. 0.53. What is the ratio of the Net Disbursements (current US$) in Kazakhstan in 2007 to that in 2008?
Ensure brevity in your answer.  4.65. What is the ratio of the Net Disbursements (current US$) of East Asia (developing only) in 2007 to that in 2009?
Keep it short and to the point. 2.09. What is the ratio of the Net Disbursements (current US$) of Georgia in 2007 to that in 2009?
Your response must be concise. 0.14. What is the ratio of the Net Disbursements (current US$) in India in 2007 to that in 2009?
Keep it short and to the point. 1.73. What is the ratio of the Net Disbursements (current US$) in Kazakhstan in 2007 to that in 2009?
Provide a succinct answer. 1.11. What is the ratio of the Net Disbursements (current US$) in East Asia (developing only) in 2007 to that in 2010?
Provide a short and direct response. 1.37. What is the ratio of the Net Disbursements (current US$) of Georgia in 2007 to that in 2010?
Provide a succinct answer. 0.25. What is the ratio of the Net Disbursements (current US$) of Kazakhstan in 2007 to that in 2010?
Your answer should be very brief. 1.16. What is the ratio of the Net Disbursements (current US$) of East Asia (developing only) in 2007 to that in 2011?
Give a very brief answer. 16.17. What is the ratio of the Net Disbursements (current US$) in Georgia in 2007 to that in 2011?
Your response must be concise. 0.24. What is the ratio of the Net Disbursements (current US$) in India in 2007 to that in 2011?
Ensure brevity in your answer.  1.46. What is the ratio of the Net Disbursements (current US$) in Kazakhstan in 2007 to that in 2011?
Provide a short and direct response. 1.21. What is the ratio of the Net Disbursements (current US$) of East Asia (developing only) in 2007 to that in 2012?
Provide a succinct answer. 1.33. What is the ratio of the Net Disbursements (current US$) in Georgia in 2007 to that in 2012?
Offer a very short reply. 0.6. What is the ratio of the Net Disbursements (current US$) in India in 2007 to that in 2012?
Keep it short and to the point. 1.46. What is the ratio of the Net Disbursements (current US$) in Kazakhstan in 2007 to that in 2012?
Your answer should be very brief. 1.55. What is the ratio of the Net Disbursements (current US$) in East Asia (developing only) in 2008 to that in 2009?
Make the answer very short. 0.62. What is the ratio of the Net Disbursements (current US$) of Georgia in 2008 to that in 2009?
Offer a very short reply. 0.26. What is the ratio of the Net Disbursements (current US$) in India in 2008 to that in 2009?
Give a very brief answer. 3.27. What is the ratio of the Net Disbursements (current US$) in Kazakhstan in 2008 to that in 2009?
Keep it short and to the point. 0.24. What is the ratio of the Net Disbursements (current US$) of East Asia (developing only) in 2008 to that in 2010?
Provide a succinct answer. 0.41. What is the ratio of the Net Disbursements (current US$) in Georgia in 2008 to that in 2010?
Your response must be concise. 0.47. What is the ratio of the Net Disbursements (current US$) of India in 2008 to that in 2010?
Provide a short and direct response. 1.89. What is the ratio of the Net Disbursements (current US$) in Kazakhstan in 2008 to that in 2010?
Your answer should be compact. 0.25. What is the ratio of the Net Disbursements (current US$) of East Asia (developing only) in 2008 to that in 2011?
Your response must be concise. 4.83. What is the ratio of the Net Disbursements (current US$) of Georgia in 2008 to that in 2011?
Give a very brief answer. 0.44. What is the ratio of the Net Disbursements (current US$) in India in 2008 to that in 2011?
Provide a succinct answer. 2.77. What is the ratio of the Net Disbursements (current US$) of Kazakhstan in 2008 to that in 2011?
Provide a short and direct response. 0.26. What is the ratio of the Net Disbursements (current US$) of East Asia (developing only) in 2008 to that in 2012?
Make the answer very short. 0.4. What is the ratio of the Net Disbursements (current US$) in Georgia in 2008 to that in 2012?
Provide a short and direct response. 1.12. What is the ratio of the Net Disbursements (current US$) of India in 2008 to that in 2012?
Make the answer very short. 2.77. What is the ratio of the Net Disbursements (current US$) of Kazakhstan in 2008 to that in 2012?
Your answer should be very brief. 0.33. What is the ratio of the Net Disbursements (current US$) in East Asia (developing only) in 2009 to that in 2010?
Your answer should be compact. 0.66. What is the ratio of the Net Disbursements (current US$) of Georgia in 2009 to that in 2010?
Your answer should be very brief. 1.81. What is the ratio of the Net Disbursements (current US$) of India in 2009 to that in 2010?
Your answer should be very brief. 0.58. What is the ratio of the Net Disbursements (current US$) of Kazakhstan in 2009 to that in 2010?
Provide a succinct answer. 1.04. What is the ratio of the Net Disbursements (current US$) of East Asia (developing only) in 2009 to that in 2011?
Make the answer very short. 7.76. What is the ratio of the Net Disbursements (current US$) of Georgia in 2009 to that in 2011?
Your response must be concise. 1.7. What is the ratio of the Net Disbursements (current US$) in India in 2009 to that in 2011?
Offer a terse response. 0.85. What is the ratio of the Net Disbursements (current US$) of Kazakhstan in 2009 to that in 2011?
Your answer should be very brief. 1.09. What is the ratio of the Net Disbursements (current US$) of East Asia (developing only) in 2009 to that in 2012?
Your answer should be very brief. 0.64. What is the ratio of the Net Disbursements (current US$) of Georgia in 2009 to that in 2012?
Provide a short and direct response. 4.34. What is the ratio of the Net Disbursements (current US$) of India in 2009 to that in 2012?
Offer a very short reply. 0.85. What is the ratio of the Net Disbursements (current US$) in Kazakhstan in 2009 to that in 2012?
Your answer should be very brief. 1.4. What is the ratio of the Net Disbursements (current US$) of East Asia (developing only) in 2010 to that in 2011?
Make the answer very short. 11.84. What is the ratio of the Net Disbursements (current US$) in Georgia in 2010 to that in 2011?
Give a very brief answer. 0.94. What is the ratio of the Net Disbursements (current US$) in India in 2010 to that in 2011?
Your answer should be very brief. 1.46. What is the ratio of the Net Disbursements (current US$) in Kazakhstan in 2010 to that in 2011?
Your response must be concise. 1.05. What is the ratio of the Net Disbursements (current US$) in East Asia (developing only) in 2010 to that in 2012?
Your response must be concise. 0.97. What is the ratio of the Net Disbursements (current US$) of Georgia in 2010 to that in 2012?
Offer a very short reply. 2.4. What is the ratio of the Net Disbursements (current US$) of India in 2010 to that in 2012?
Ensure brevity in your answer.  1.46. What is the ratio of the Net Disbursements (current US$) of Kazakhstan in 2010 to that in 2012?
Give a very brief answer. 1.34. What is the ratio of the Net Disbursements (current US$) in East Asia (developing only) in 2011 to that in 2012?
Provide a short and direct response. 0.08. What is the ratio of the Net Disbursements (current US$) in Georgia in 2011 to that in 2012?
Your response must be concise. 2.55. What is the ratio of the Net Disbursements (current US$) of India in 2011 to that in 2012?
Make the answer very short. 1. What is the ratio of the Net Disbursements (current US$) of Kazakhstan in 2011 to that in 2012?
Make the answer very short. 1.28. What is the difference between the highest and the second highest Net Disbursements (current US$) of East Asia (developing only)?
Your answer should be very brief. 1.69e+07. What is the difference between the highest and the second highest Net Disbursements (current US$) of Georgia?
Provide a succinct answer. 4.61e+06. What is the difference between the highest and the second highest Net Disbursements (current US$) in Kazakhstan?
Offer a terse response. 2.50e+05. What is the difference between the highest and the lowest Net Disbursements (current US$) in East Asia (developing only)?
Keep it short and to the point. 6.44e+07. What is the difference between the highest and the lowest Net Disbursements (current US$) of Georgia?
Keep it short and to the point. 1.07e+07. What is the difference between the highest and the lowest Net Disbursements (current US$) in India?
Your response must be concise. 3.20e+05. What is the difference between the highest and the lowest Net Disbursements (current US$) in Kazakhstan?
Provide a short and direct response. 1.97e+06. 